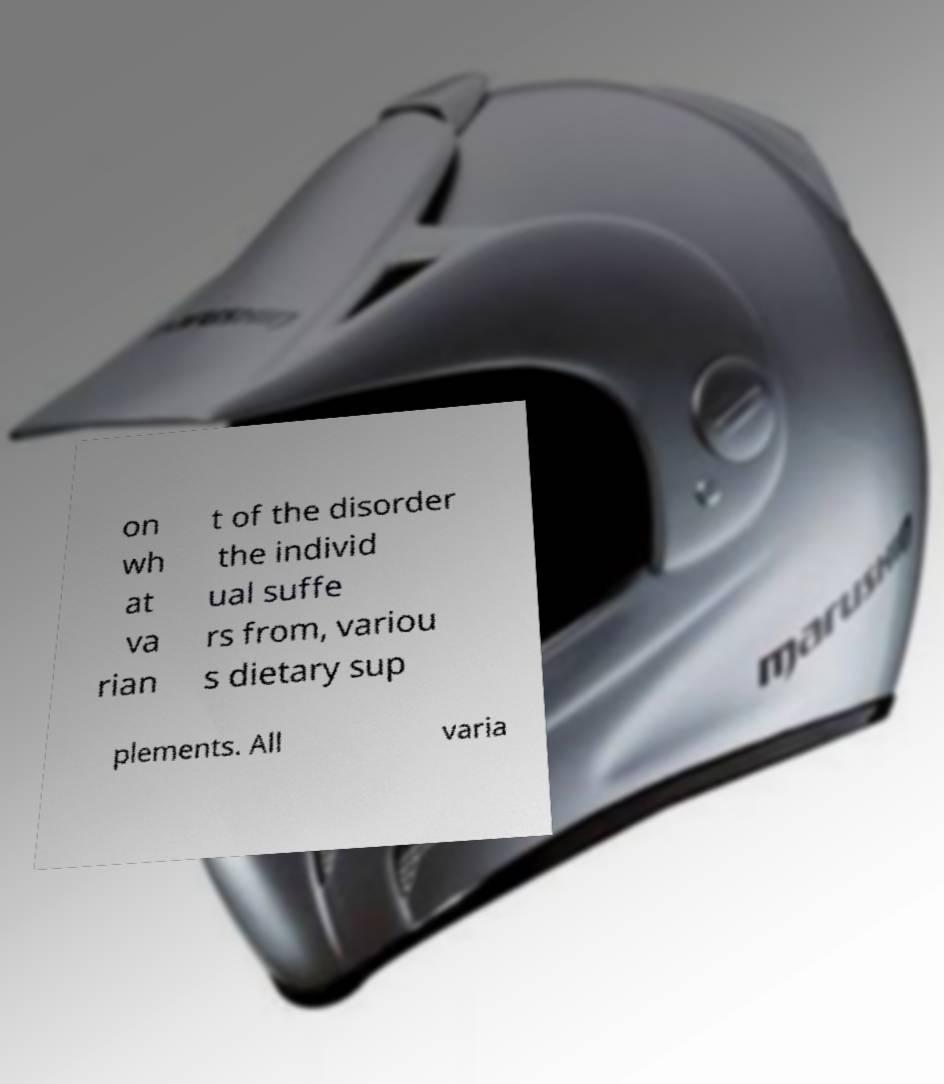Please identify and transcribe the text found in this image. on wh at va rian t of the disorder the individ ual suffe rs from, variou s dietary sup plements. All varia 